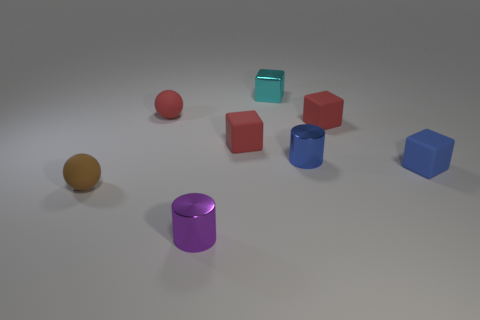Add 1 small cyan cubes. How many objects exist? 9 Subtract all cylinders. How many objects are left? 6 Add 6 small red cubes. How many small red cubes are left? 8 Add 2 big metal things. How many big metal things exist? 2 Subtract 0 green balls. How many objects are left? 8 Subtract all purple cylinders. Subtract all cubes. How many objects are left? 3 